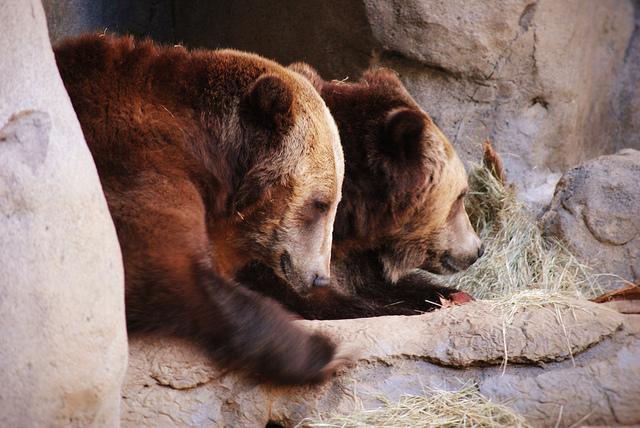How many bears are there?
Answer briefly. 2. Are these polar bears?
Quick response, please. No. What are the bears doing?
Quick response, please. Resting. 